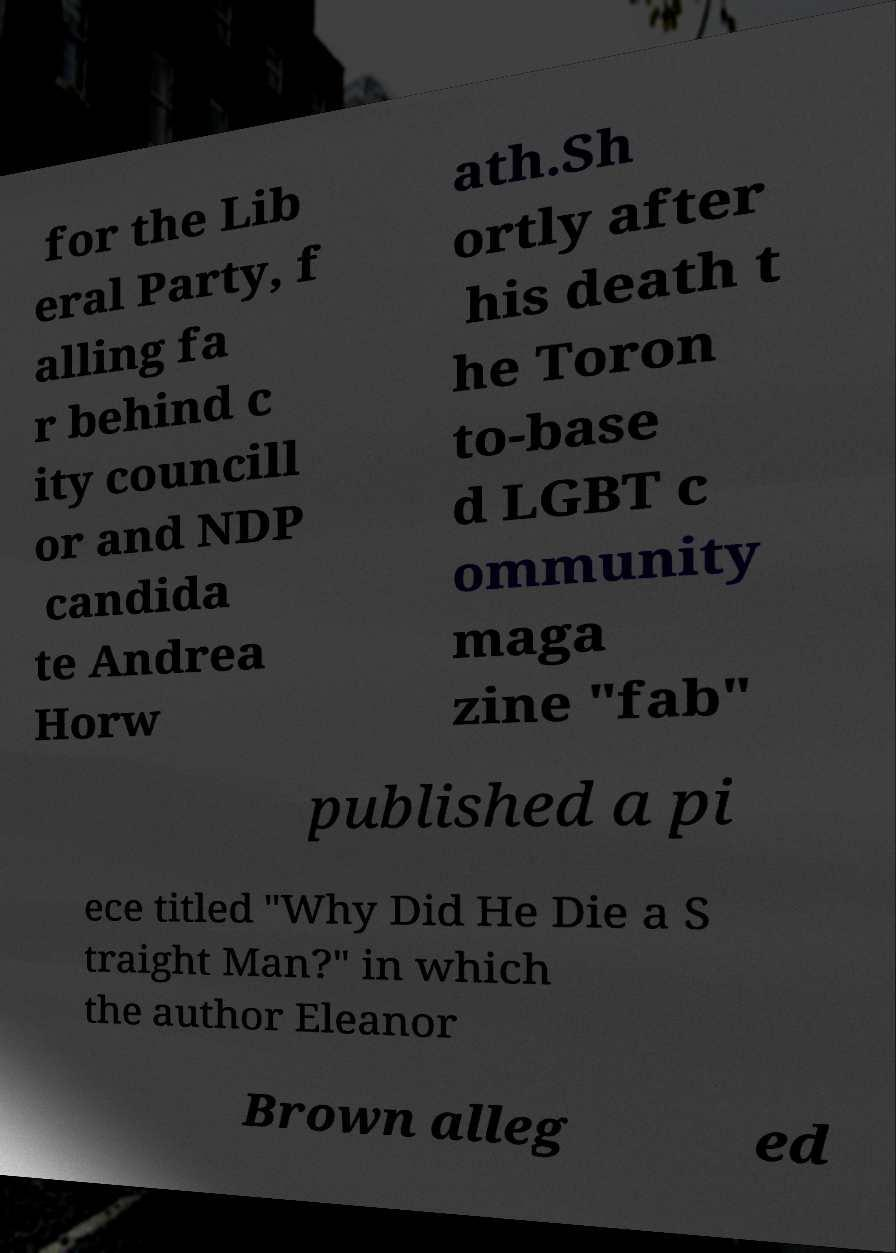Can you accurately transcribe the text from the provided image for me? for the Lib eral Party, f alling fa r behind c ity councill or and NDP candida te Andrea Horw ath.Sh ortly after his death t he Toron to-base d LGBT c ommunity maga zine "fab" published a pi ece titled "Why Did He Die a S traight Man?" in which the author Eleanor Brown alleg ed 